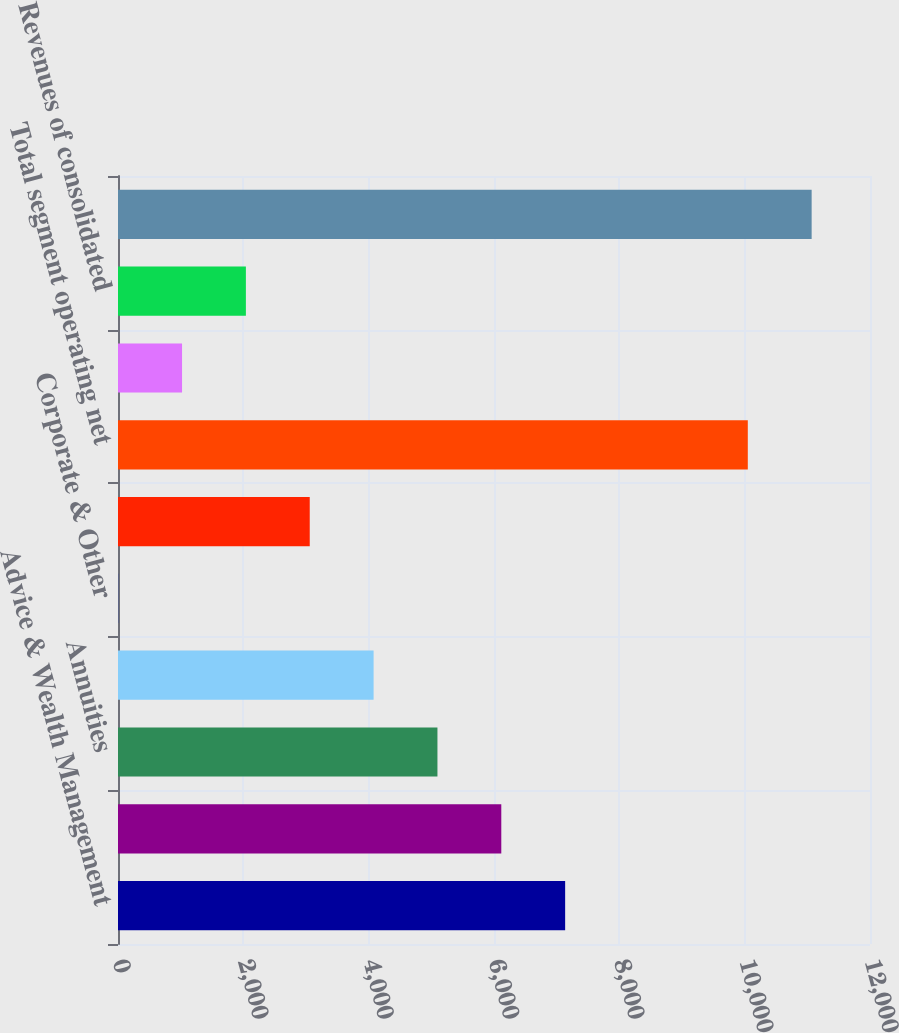Convert chart to OTSL. <chart><loc_0><loc_0><loc_500><loc_500><bar_chart><fcel>Advice & Wealth Management<fcel>Asset Management<fcel>Annuities<fcel>Protection<fcel>Corporate & Other<fcel>Eliminations (1)<fcel>Total segment operating net<fcel>Net realized gains<fcel>Revenues of consolidated<fcel>Total net revenues per<nl><fcel>7135.3<fcel>6116.4<fcel>5097.5<fcel>4078.6<fcel>3<fcel>3059.7<fcel>10050<fcel>1021.9<fcel>2040.8<fcel>11068.9<nl></chart> 